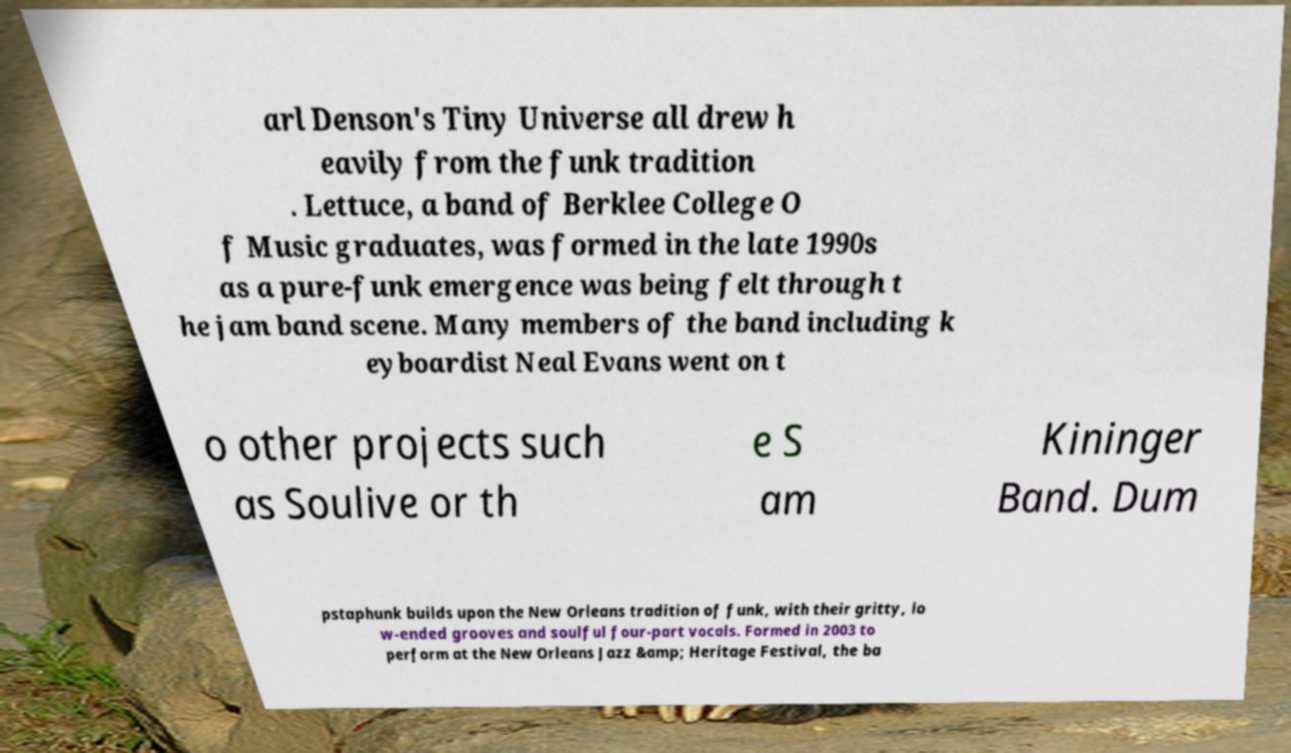There's text embedded in this image that I need extracted. Can you transcribe it verbatim? arl Denson's Tiny Universe all drew h eavily from the funk tradition . Lettuce, a band of Berklee College O f Music graduates, was formed in the late 1990s as a pure-funk emergence was being felt through t he jam band scene. Many members of the band including k eyboardist Neal Evans went on t o other projects such as Soulive or th e S am Kininger Band. Dum pstaphunk builds upon the New Orleans tradition of funk, with their gritty, lo w-ended grooves and soulful four-part vocals. Formed in 2003 to perform at the New Orleans Jazz &amp; Heritage Festival, the ba 